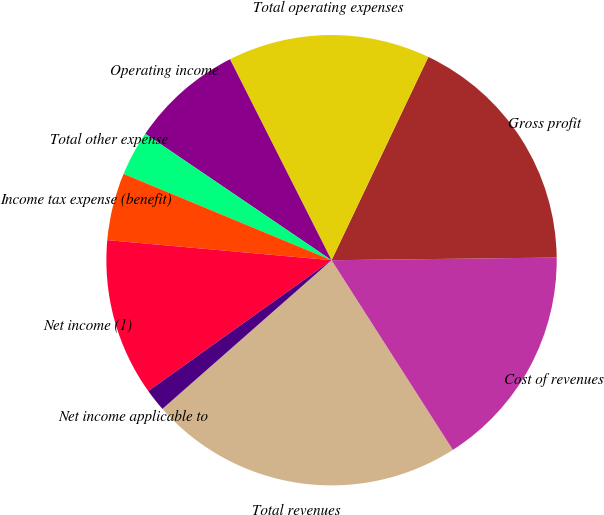Convert chart to OTSL. <chart><loc_0><loc_0><loc_500><loc_500><pie_chart><fcel>Total revenues<fcel>Cost of revenues<fcel>Gross profit<fcel>Total operating expenses<fcel>Operating income<fcel>Total other expense<fcel>Income tax expense (benefit)<fcel>Net income (1)<fcel>Net income applicable to<nl><fcel>22.58%<fcel>16.13%<fcel>17.74%<fcel>14.52%<fcel>8.06%<fcel>3.23%<fcel>4.84%<fcel>11.29%<fcel>1.61%<nl></chart> 